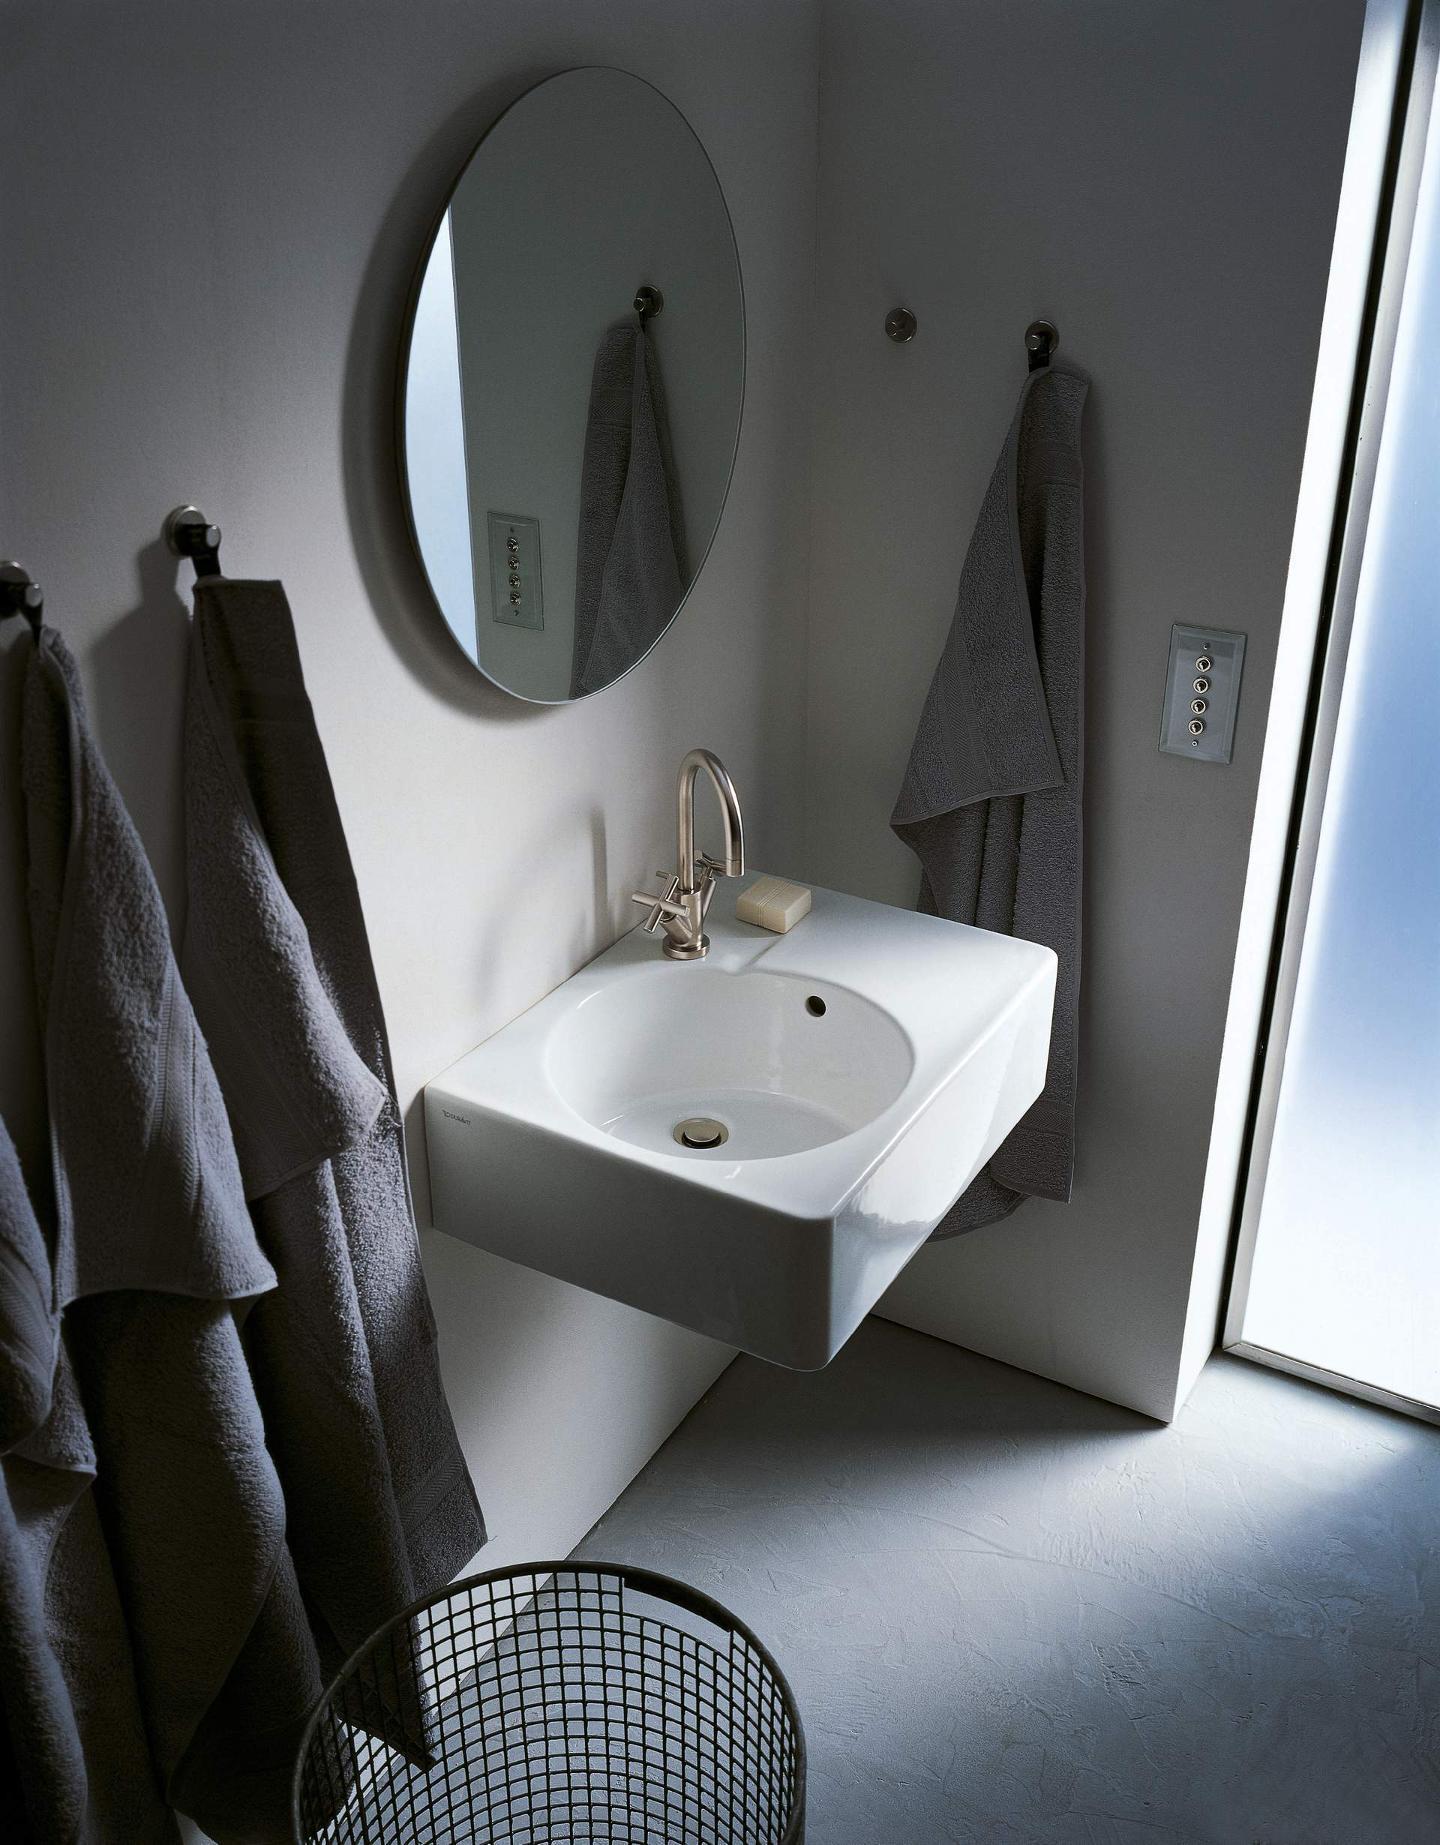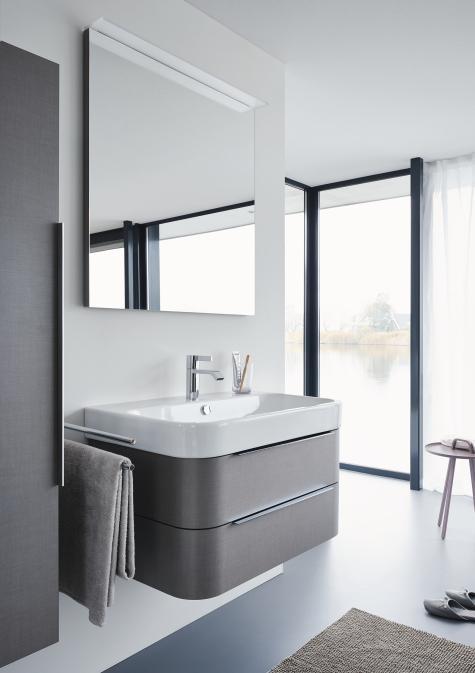The first image is the image on the left, the second image is the image on the right. Analyze the images presented: Is the assertion "The left image features at least one round sink inset in white and mounted on the wall, and the right image features a rectangular white sink." valid? Answer yes or no. Yes. The first image is the image on the left, the second image is the image on the right. Assess this claim about the two images: "There is a mirror positioned above every sink basin.". Correct or not? Answer yes or no. Yes. 